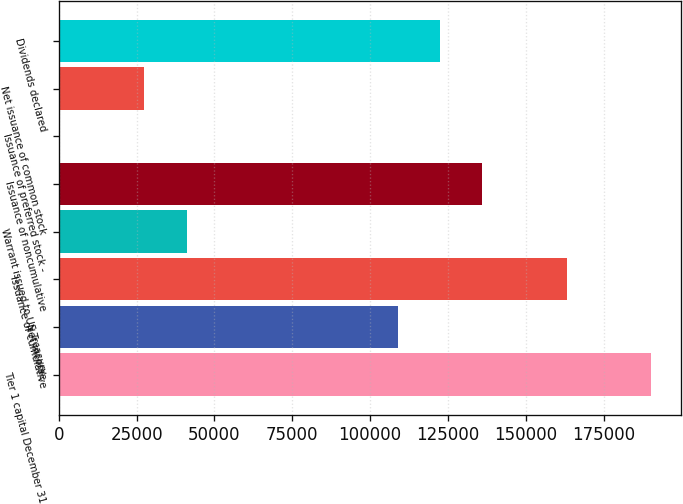<chart> <loc_0><loc_0><loc_500><loc_500><bar_chart><fcel>Tier 1 capital December 31<fcel>Net income<fcel>Issuance of cumulative<fcel>Warrant issued to US Treasury<fcel>Issuance of noncumulative<fcel>Issuance of preferred stock -<fcel>Net issuance of common stock<fcel>Dividends declared<nl><fcel>190405<fcel>108954<fcel>163254<fcel>41077.6<fcel>136104<fcel>352<fcel>27502.4<fcel>122529<nl></chart> 